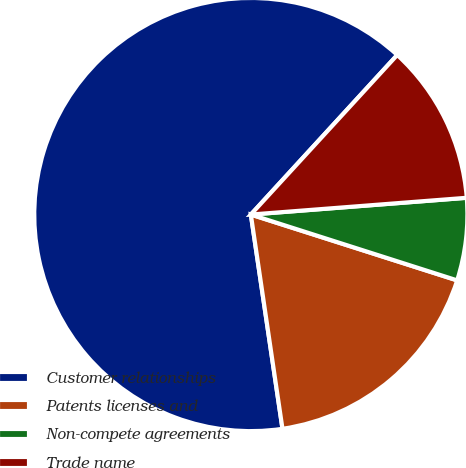Convert chart to OTSL. <chart><loc_0><loc_0><loc_500><loc_500><pie_chart><fcel>Customer relationships<fcel>Patents licenses and<fcel>Non-compete agreements<fcel>Trade name<nl><fcel>64.15%<fcel>17.75%<fcel>6.15%<fcel>11.95%<nl></chart> 